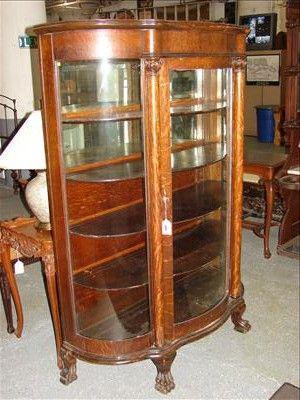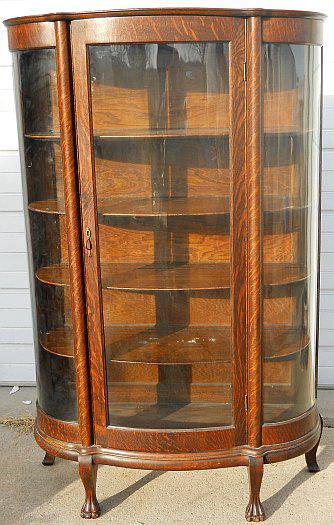The first image is the image on the left, the second image is the image on the right. Analyze the images presented: Is the assertion "There are two empty wooden curio cabinets with glass fronts." valid? Answer yes or no. Yes. The first image is the image on the left, the second image is the image on the right. Given the left and right images, does the statement "There are two wood and glass cabinets, and they are both empty." hold true? Answer yes or no. Yes. 